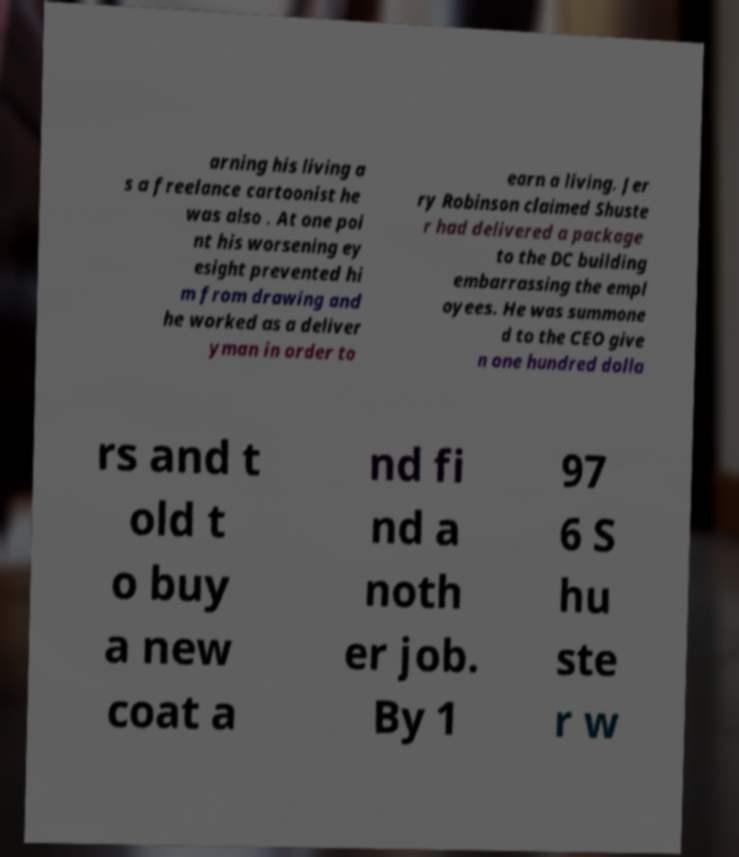Please identify and transcribe the text found in this image. arning his living a s a freelance cartoonist he was also . At one poi nt his worsening ey esight prevented hi m from drawing and he worked as a deliver yman in order to earn a living. Jer ry Robinson claimed Shuste r had delivered a package to the DC building embarrassing the empl oyees. He was summone d to the CEO give n one hundred dolla rs and t old t o buy a new coat a nd fi nd a noth er job. By 1 97 6 S hu ste r w 